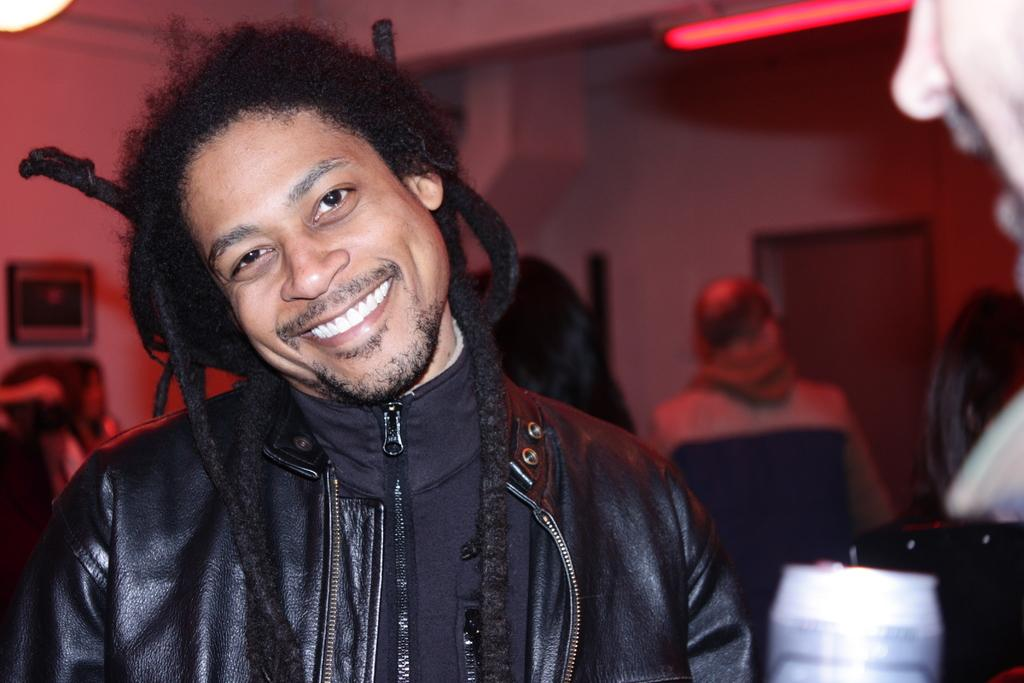How many people are in the image? There are people in the image, but the exact number is not specified. What is the person holding in the image? One person is holding an object in the image. Where is the door located in the image? There is a door in the image, but its location is not specified. What type of light is visible in the image? There is a light in the image, but its specific type is not mentioned. What is hanging on the wall in the image? There is a photo frame on the wall in the image. What type of system is being compared in the image? There is no system or comparison present in the image; it features people, an object, a door, a light, and a photo frame. 